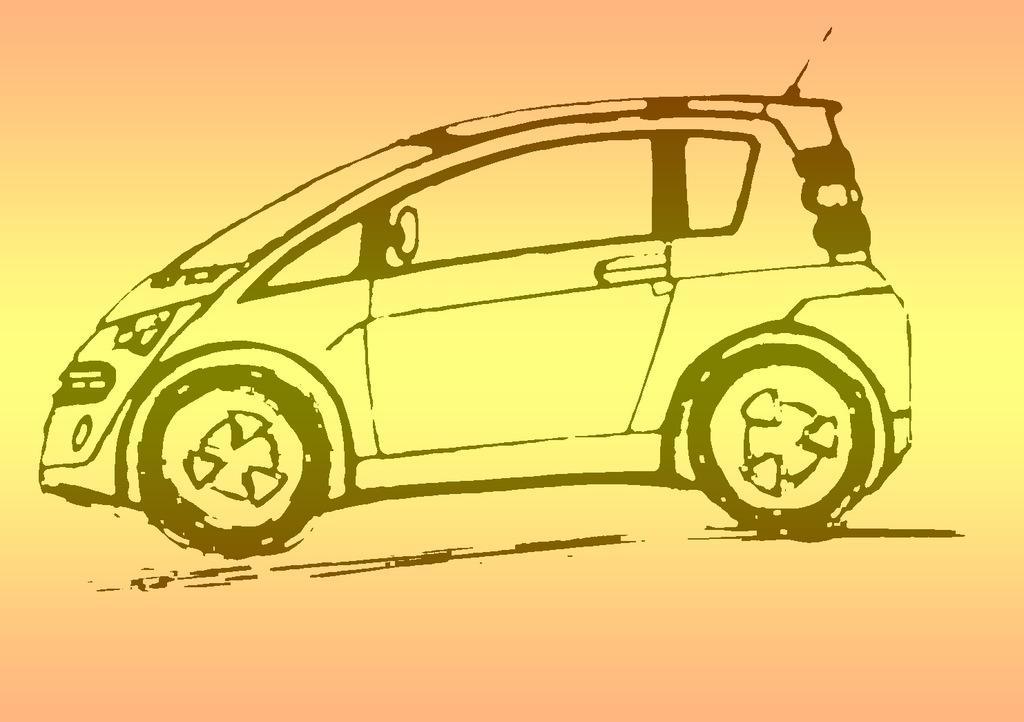Please provide a concise description of this image. In the image we can see a drawing of the car and the image is pale orange and pale yellow in color. 